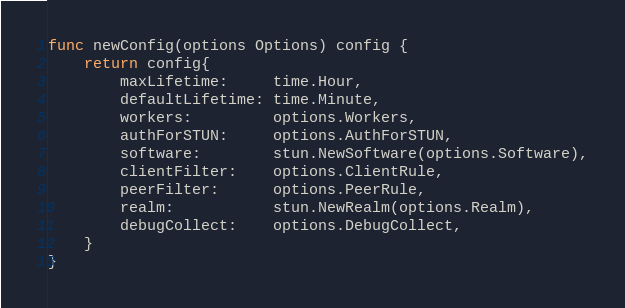<code> <loc_0><loc_0><loc_500><loc_500><_Go_>
func newConfig(options Options) config {
	return config{
		maxLifetime:     time.Hour,
		defaultLifetime: time.Minute,
		workers:         options.Workers,
		authForSTUN:     options.AuthForSTUN,
		software:        stun.NewSoftware(options.Software),
		clientFilter:    options.ClientRule,
		peerFilter:      options.PeerRule,
		realm:           stun.NewRealm(options.Realm),
		debugCollect:    options.DebugCollect,
	}
}
</code> 